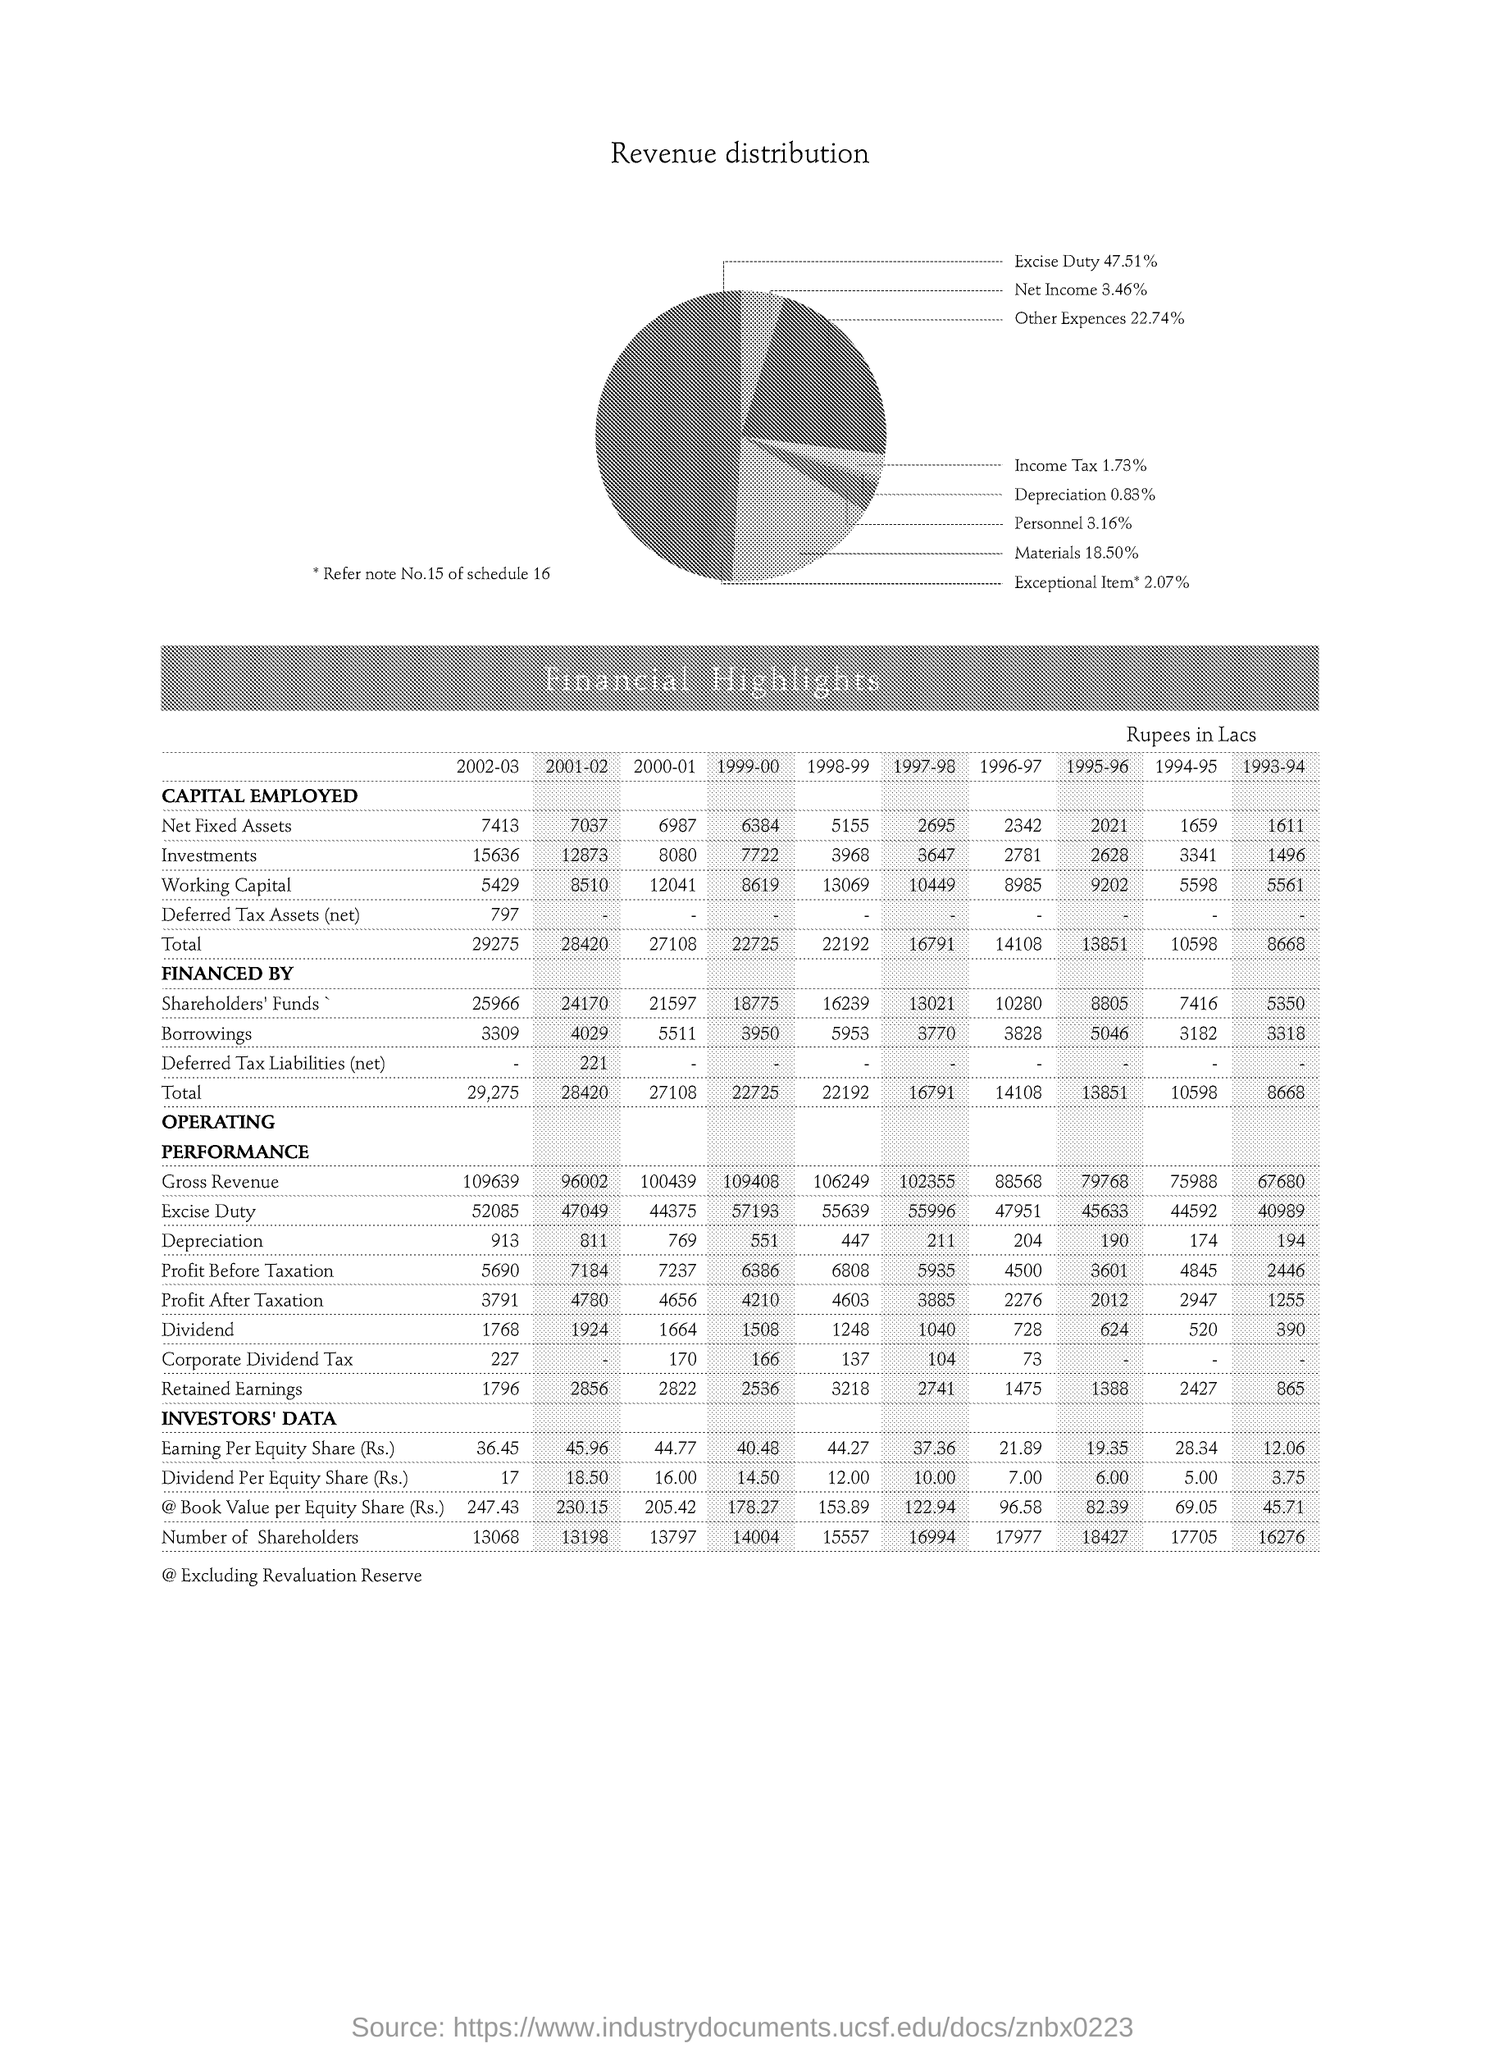Outline some significant characteristics in this image. Approximately 18.50% of the materials used were consumed. The net income is 3.46%. In 2001-2002, the smallest amount was 18.50. In the year 2002-2003, the amount of borrowings was approximately 3,309. The percentage of other expenses is 22.74%. 